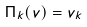Convert formula to latex. <formula><loc_0><loc_0><loc_500><loc_500>\Pi _ { k } ( v ) = v _ { k }</formula> 